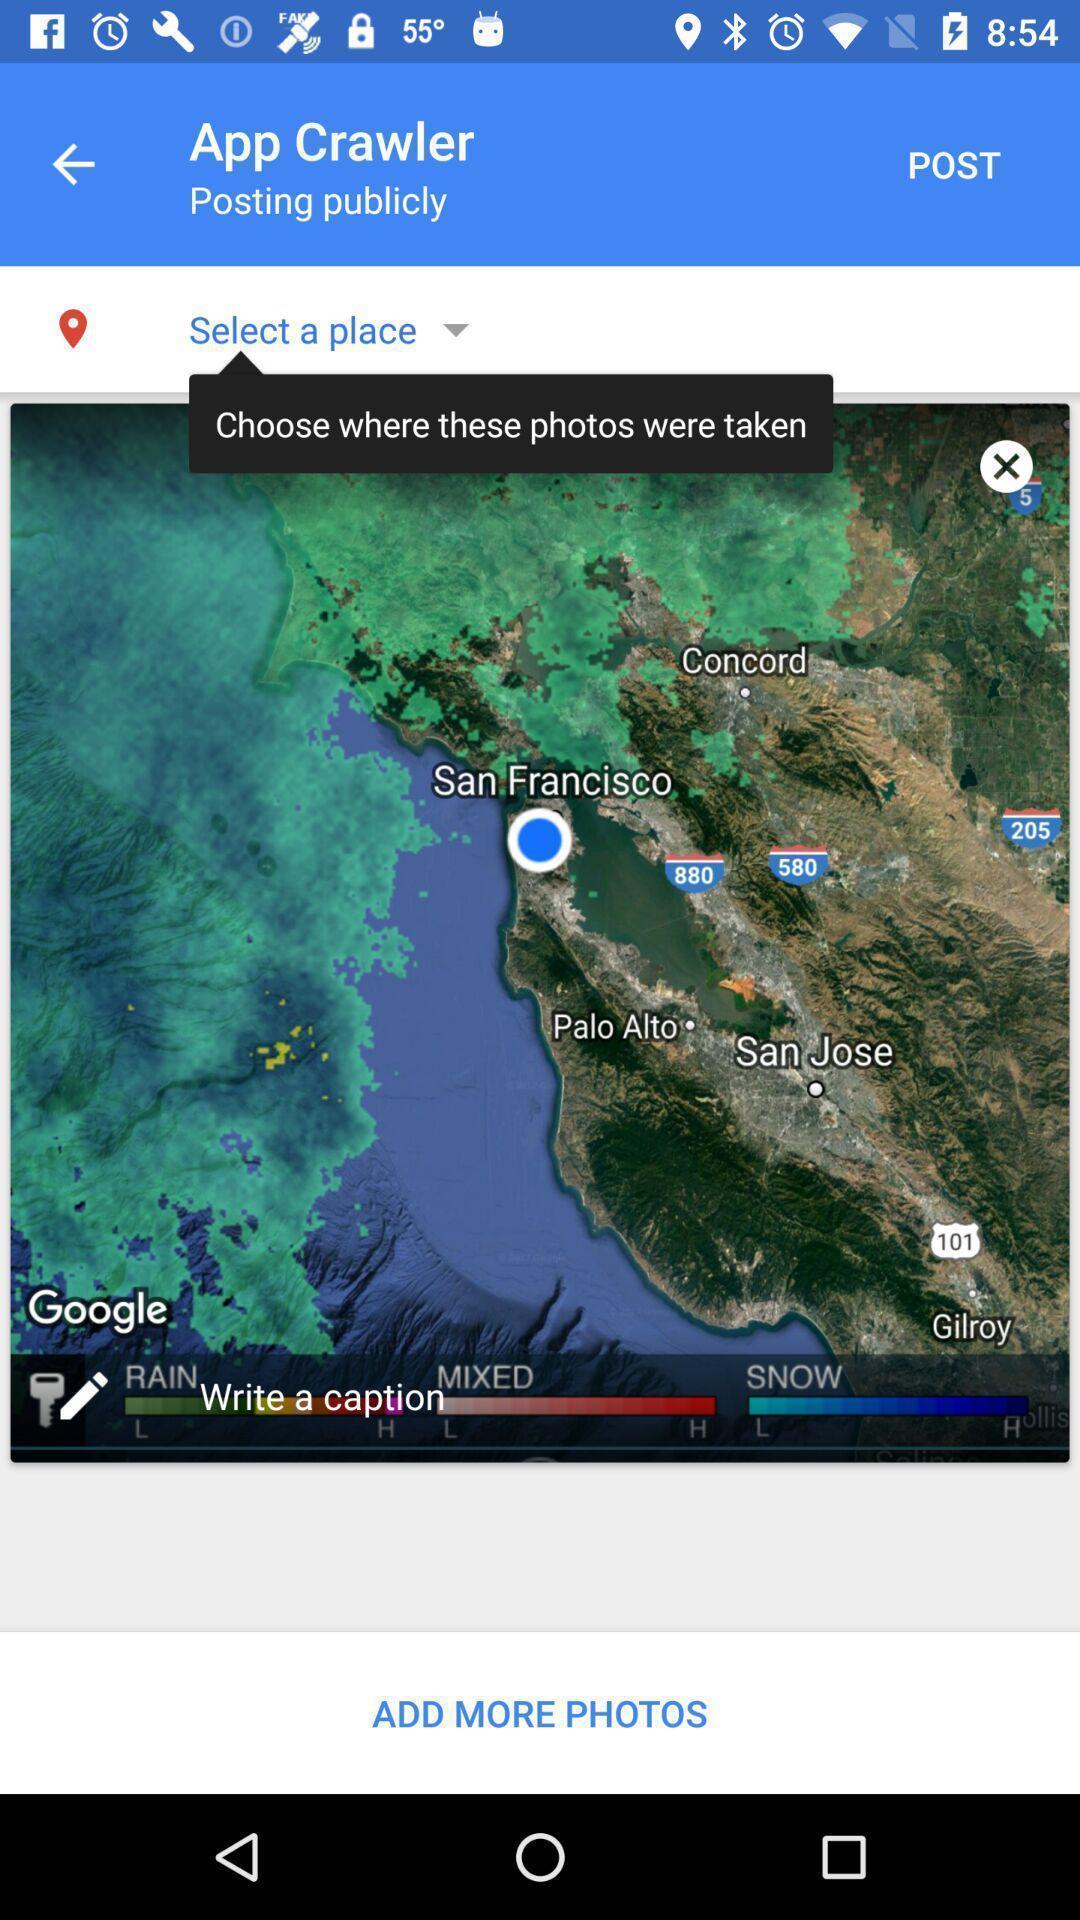What details can you identify in this image? Screen displaying a map view in a weather application. 